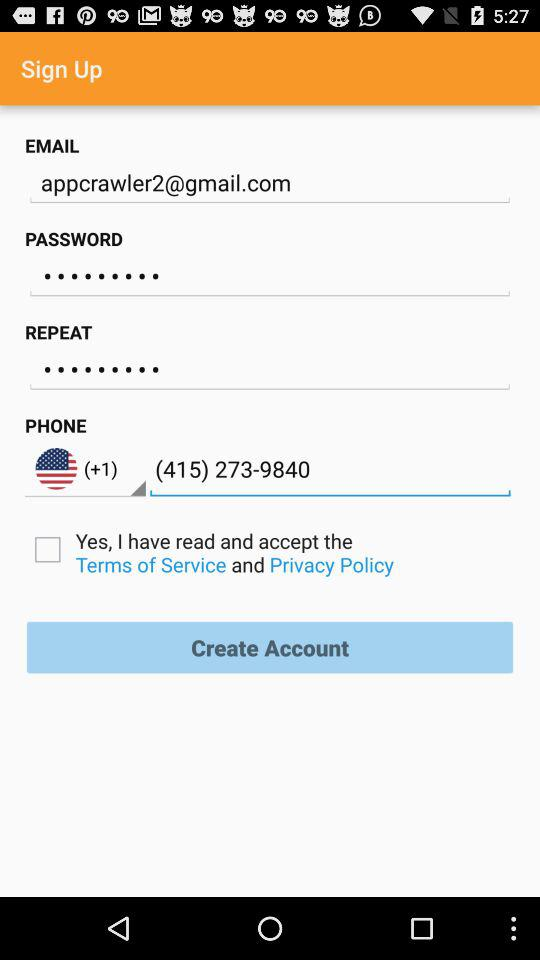What is the phone number? The phone number is (+1) (415) 273-9840. 